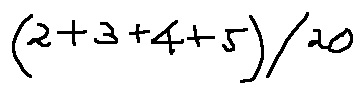<formula> <loc_0><loc_0><loc_500><loc_500>( 2 + 3 + 4 + 5 ) / 2 0</formula> 